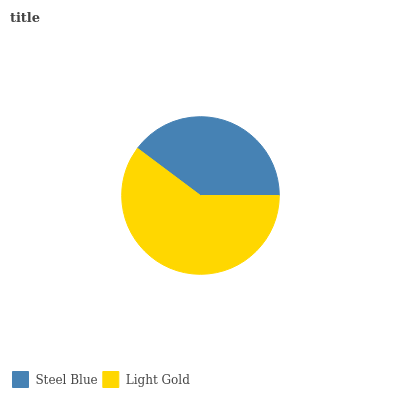Is Steel Blue the minimum?
Answer yes or no. Yes. Is Light Gold the maximum?
Answer yes or no. Yes. Is Light Gold the minimum?
Answer yes or no. No. Is Light Gold greater than Steel Blue?
Answer yes or no. Yes. Is Steel Blue less than Light Gold?
Answer yes or no. Yes. Is Steel Blue greater than Light Gold?
Answer yes or no. No. Is Light Gold less than Steel Blue?
Answer yes or no. No. Is Light Gold the high median?
Answer yes or no. Yes. Is Steel Blue the low median?
Answer yes or no. Yes. Is Steel Blue the high median?
Answer yes or no. No. Is Light Gold the low median?
Answer yes or no. No. 